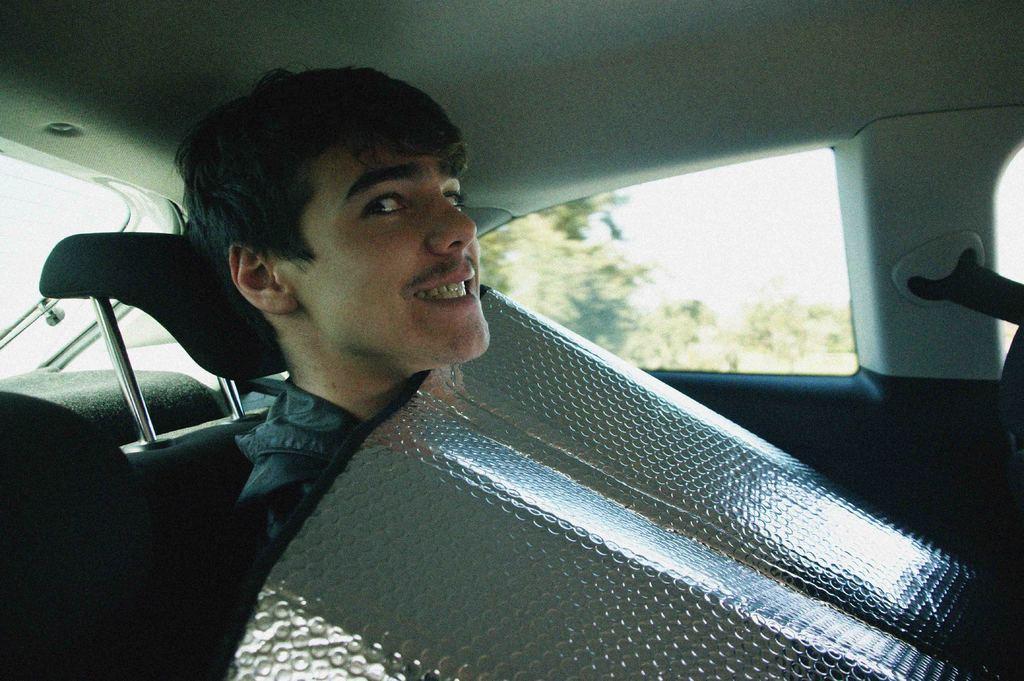Can you describe this image briefly? This picture is clicked inside the vehicle. In the center we can see a man sitting on the seat and we can see an object. In the background we can see the window and through the window we can see the outside view. 